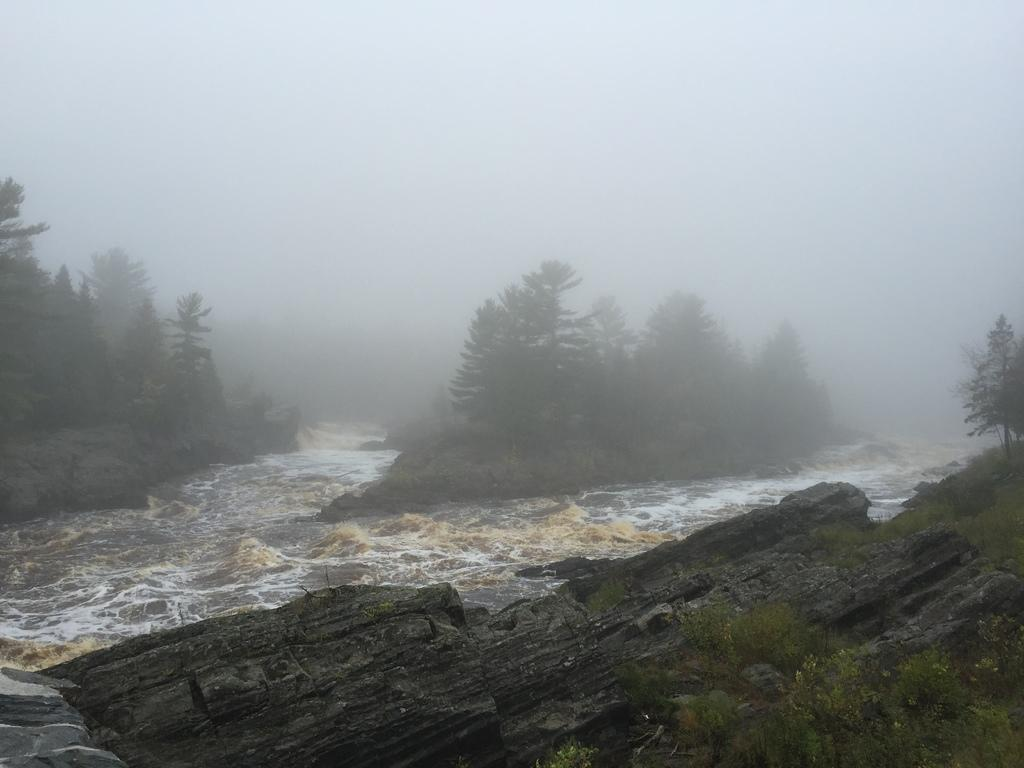What is the primary element visible in the image? There is water in the image. What other objects or features can be seen in the image? There are rocks, plants, and trees in the image. What can be seen in the background of the image? The sky is visible in the background of the image. Where is the baby in the image? There is no baby present in the image. What type of egg can be seen in the image? There are no eggs present in the image. 